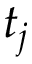Convert formula to latex. <formula><loc_0><loc_0><loc_500><loc_500>t _ { j }</formula> 